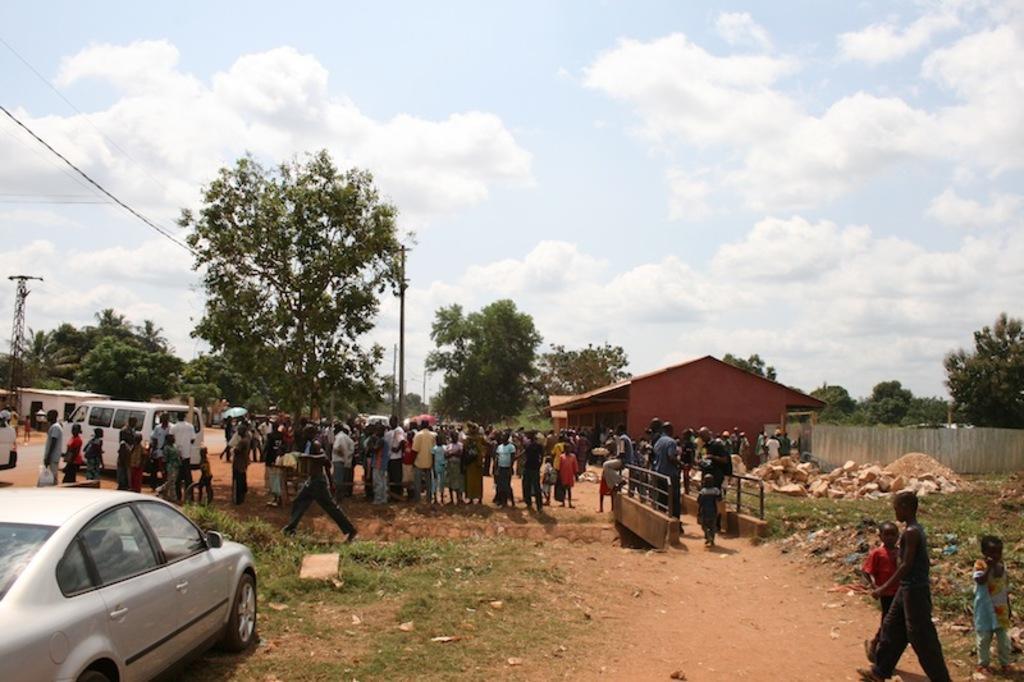Describe this image in one or two sentences. In this picture we can observe some vehicles parked on the land. There are some people standing. There are men and women in this picture. We can observe trees and a sky with some clouds. 